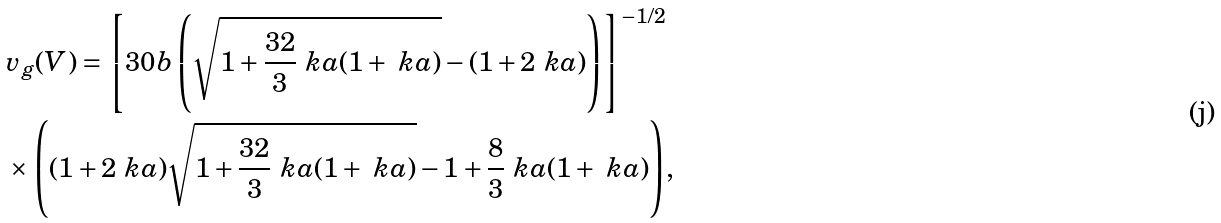Convert formula to latex. <formula><loc_0><loc_0><loc_500><loc_500>& v _ { g } ( V ) = { \left [ 3 0 b \left ( \sqrt { 1 + \frac { 3 2 } { 3 } \ k a ( 1 + \ k a ) } - ( 1 + 2 \ k a ) \right ) \right ] ^ { - 1 / 2 } } \\ & \times { \left ( ( 1 + 2 \ k a ) \sqrt { 1 + \frac { 3 2 } { 3 } \ k a ( 1 + \ k a ) } - 1 + \frac { 8 } { 3 } \ k a ( 1 + \ k a ) \right ) } ,</formula> 